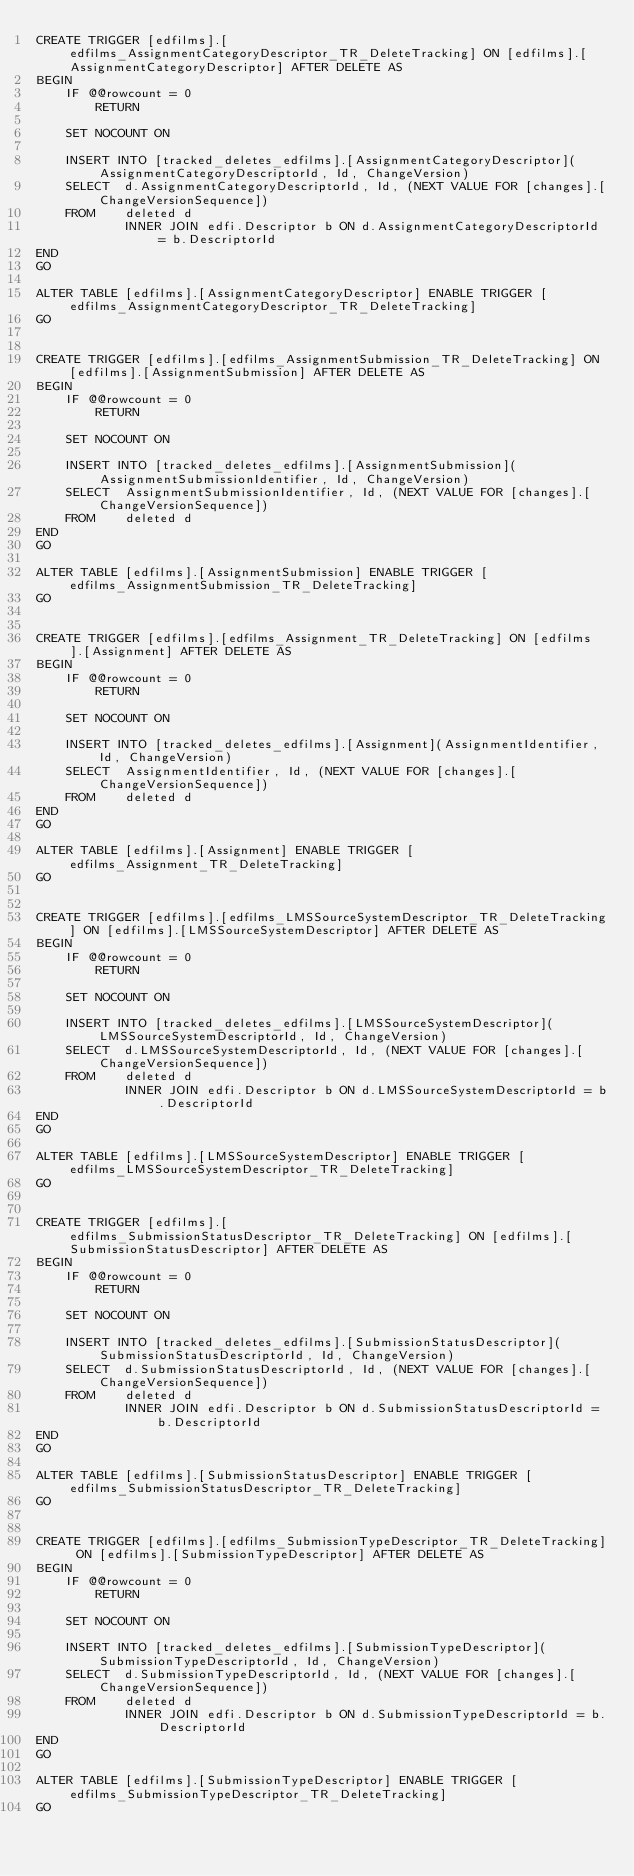Convert code to text. <code><loc_0><loc_0><loc_500><loc_500><_SQL_>CREATE TRIGGER [edfilms].[edfilms_AssignmentCategoryDescriptor_TR_DeleteTracking] ON [edfilms].[AssignmentCategoryDescriptor] AFTER DELETE AS
BEGIN
    IF @@rowcount = 0 
        RETURN

    SET NOCOUNT ON

    INSERT INTO [tracked_deletes_edfilms].[AssignmentCategoryDescriptor](AssignmentCategoryDescriptorId, Id, ChangeVersion)
    SELECT  d.AssignmentCategoryDescriptorId, Id, (NEXT VALUE FOR [changes].[ChangeVersionSequence])
    FROM    deleted d
            INNER JOIN edfi.Descriptor b ON d.AssignmentCategoryDescriptorId = b.DescriptorId
END
GO

ALTER TABLE [edfilms].[AssignmentCategoryDescriptor] ENABLE TRIGGER [edfilms_AssignmentCategoryDescriptor_TR_DeleteTracking]
GO


CREATE TRIGGER [edfilms].[edfilms_AssignmentSubmission_TR_DeleteTracking] ON [edfilms].[AssignmentSubmission] AFTER DELETE AS
BEGIN
    IF @@rowcount = 0 
        RETURN

    SET NOCOUNT ON

    INSERT INTO [tracked_deletes_edfilms].[AssignmentSubmission](AssignmentSubmissionIdentifier, Id, ChangeVersion)
    SELECT  AssignmentSubmissionIdentifier, Id, (NEXT VALUE FOR [changes].[ChangeVersionSequence])
    FROM    deleted d
END
GO

ALTER TABLE [edfilms].[AssignmentSubmission] ENABLE TRIGGER [edfilms_AssignmentSubmission_TR_DeleteTracking]
GO


CREATE TRIGGER [edfilms].[edfilms_Assignment_TR_DeleteTracking] ON [edfilms].[Assignment] AFTER DELETE AS
BEGIN
    IF @@rowcount = 0 
        RETURN

    SET NOCOUNT ON

    INSERT INTO [tracked_deletes_edfilms].[Assignment](AssignmentIdentifier, Id, ChangeVersion)
    SELECT  AssignmentIdentifier, Id, (NEXT VALUE FOR [changes].[ChangeVersionSequence])
    FROM    deleted d
END
GO

ALTER TABLE [edfilms].[Assignment] ENABLE TRIGGER [edfilms_Assignment_TR_DeleteTracking]
GO


CREATE TRIGGER [edfilms].[edfilms_LMSSourceSystemDescriptor_TR_DeleteTracking] ON [edfilms].[LMSSourceSystemDescriptor] AFTER DELETE AS
BEGIN
    IF @@rowcount = 0 
        RETURN

    SET NOCOUNT ON

    INSERT INTO [tracked_deletes_edfilms].[LMSSourceSystemDescriptor](LMSSourceSystemDescriptorId, Id, ChangeVersion)
    SELECT  d.LMSSourceSystemDescriptorId, Id, (NEXT VALUE FOR [changes].[ChangeVersionSequence])
    FROM    deleted d
            INNER JOIN edfi.Descriptor b ON d.LMSSourceSystemDescriptorId = b.DescriptorId
END
GO

ALTER TABLE [edfilms].[LMSSourceSystemDescriptor] ENABLE TRIGGER [edfilms_LMSSourceSystemDescriptor_TR_DeleteTracking]
GO


CREATE TRIGGER [edfilms].[edfilms_SubmissionStatusDescriptor_TR_DeleteTracking] ON [edfilms].[SubmissionStatusDescriptor] AFTER DELETE AS
BEGIN
    IF @@rowcount = 0 
        RETURN

    SET NOCOUNT ON

    INSERT INTO [tracked_deletes_edfilms].[SubmissionStatusDescriptor](SubmissionStatusDescriptorId, Id, ChangeVersion)
    SELECT  d.SubmissionStatusDescriptorId, Id, (NEXT VALUE FOR [changes].[ChangeVersionSequence])
    FROM    deleted d
            INNER JOIN edfi.Descriptor b ON d.SubmissionStatusDescriptorId = b.DescriptorId
END
GO

ALTER TABLE [edfilms].[SubmissionStatusDescriptor] ENABLE TRIGGER [edfilms_SubmissionStatusDescriptor_TR_DeleteTracking]
GO


CREATE TRIGGER [edfilms].[edfilms_SubmissionTypeDescriptor_TR_DeleteTracking] ON [edfilms].[SubmissionTypeDescriptor] AFTER DELETE AS
BEGIN
    IF @@rowcount = 0 
        RETURN

    SET NOCOUNT ON

    INSERT INTO [tracked_deletes_edfilms].[SubmissionTypeDescriptor](SubmissionTypeDescriptorId, Id, ChangeVersion)
    SELECT  d.SubmissionTypeDescriptorId, Id, (NEXT VALUE FOR [changes].[ChangeVersionSequence])
    FROM    deleted d
            INNER JOIN edfi.Descriptor b ON d.SubmissionTypeDescriptorId = b.DescriptorId
END
GO

ALTER TABLE [edfilms].[SubmissionTypeDescriptor] ENABLE TRIGGER [edfilms_SubmissionTypeDescriptor_TR_DeleteTracking]
GO


</code> 